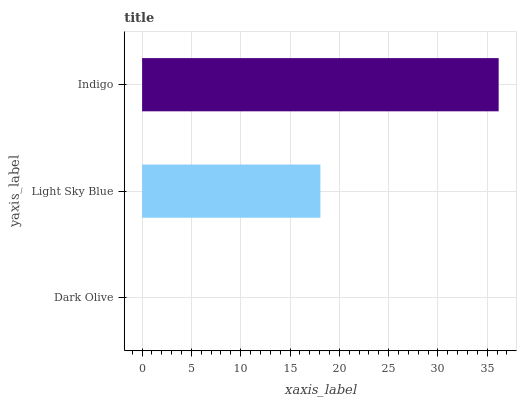Is Dark Olive the minimum?
Answer yes or no. Yes. Is Indigo the maximum?
Answer yes or no. Yes. Is Light Sky Blue the minimum?
Answer yes or no. No. Is Light Sky Blue the maximum?
Answer yes or no. No. Is Light Sky Blue greater than Dark Olive?
Answer yes or no. Yes. Is Dark Olive less than Light Sky Blue?
Answer yes or no. Yes. Is Dark Olive greater than Light Sky Blue?
Answer yes or no. No. Is Light Sky Blue less than Dark Olive?
Answer yes or no. No. Is Light Sky Blue the high median?
Answer yes or no. Yes. Is Light Sky Blue the low median?
Answer yes or no. Yes. Is Indigo the high median?
Answer yes or no. No. Is Indigo the low median?
Answer yes or no. No. 